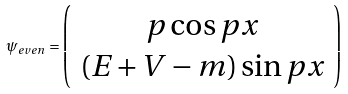<formula> <loc_0><loc_0><loc_500><loc_500>\psi _ { e v e n } = \left ( \begin{array} { c } p \cos p x \\ ( E + V - m ) \sin p x \end{array} \right )</formula> 